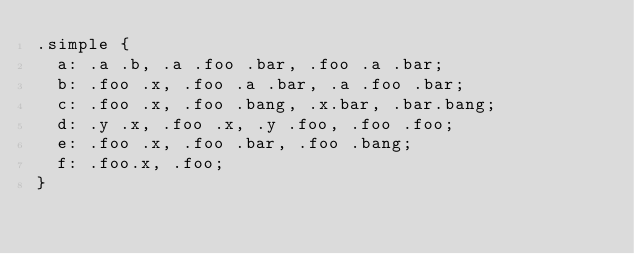<code> <loc_0><loc_0><loc_500><loc_500><_CSS_>.simple {
  a: .a .b, .a .foo .bar, .foo .a .bar;
  b: .foo .x, .foo .a .bar, .a .foo .bar;
  c: .foo .x, .foo .bang, .x.bar, .bar.bang;
  d: .y .x, .foo .x, .y .foo, .foo .foo;
  e: .foo .x, .foo .bar, .foo .bang;
  f: .foo.x, .foo;
}
</code> 